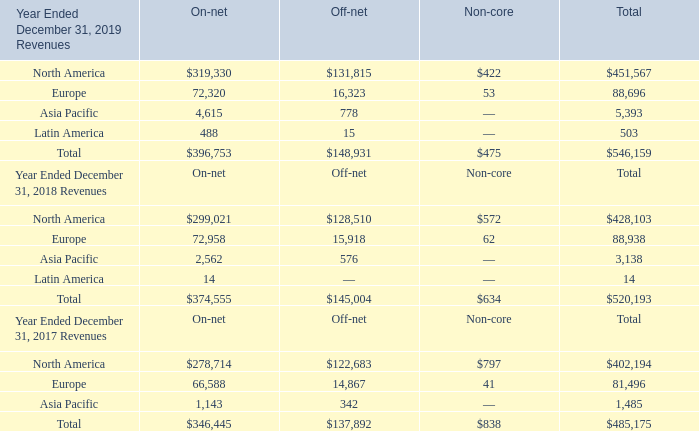10. Geographic information:
Operating segments are defined as components of an enterprise about which separate financial information is available that is evaluated regularly by the chief operating decision maker in deciding how to allocate resources and in assessing the Company’s performance. The Company has one operating segment. Revenues are attributed to regions based on where the services are provided. Below are the Company’s service revenues and long lived assets by geographic region (in thousands):
What is the value revenue from the on-net segment from North America in 2019?
Answer scale should be: thousand. $319,330. What is the value revenue from the off-net segment from North America in 2019?
Answer scale should be: thousand. $131,815. What is the value revenue from non-core segment from North America in 2019?
Answer scale should be: thousand. $422. What is the value of the revenue from the on-net segment from North America as a percentage of the total revenue earned in North America in 2019?
Answer scale should be: percent. 319,330/402,194 
Answer: 79.4. What is the value of the revenue from the off-net segment from North America as a percentage of the total revenue earned in North America in 2019?
Answer scale should be: percent. 131,815/402,194 
Answer: 32.77. What is the value of the revenue from the non-core segment from North America as a percentage of the total revenue earned in North America in 2019?
Answer scale should be: percent. 422/402,194 
Answer: 0.1. 